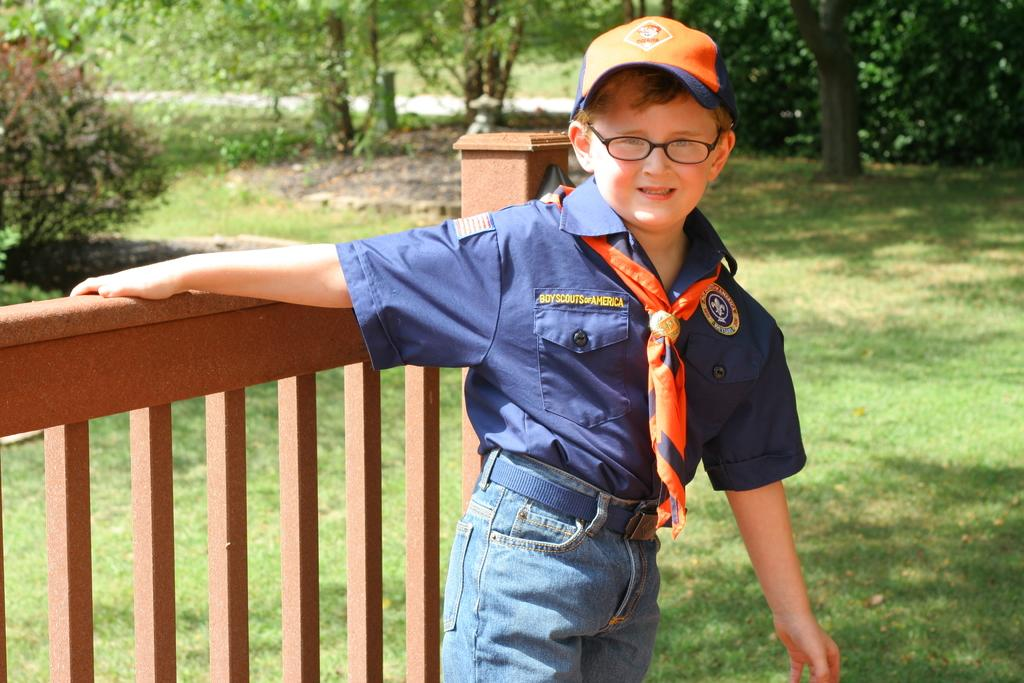What is the main subject of the image? There is a boy standing in the image. What is behind the boy in the image? There is railing behind the boy. What can be seen in the background of the image? There is grass, trees, and plants visible in the background of the image. What type of rifle is the boy holding in the image? There is no rifle present in the image; the boy is simply standing. What is the boy's annual income in the image? There is no information about the boy's income in the image. 